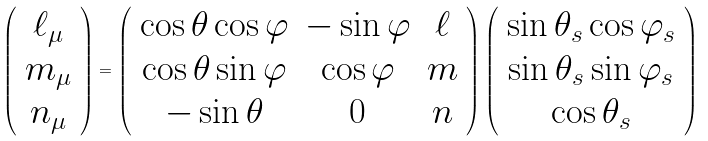Convert formula to latex. <formula><loc_0><loc_0><loc_500><loc_500>\left ( \begin{array} { c } \ell _ { \mu } \\ m _ { \mu } \\ n _ { \mu } \end{array} \right ) = \left ( \begin{array} { c c c } \cos \theta \cos \varphi & - \sin \varphi & \ell \\ \cos \theta \sin \varphi & \cos \varphi & m \\ - \sin \theta & 0 & n \end{array} \right ) \left ( \begin{array} { c } \sin \theta _ { s } \cos \varphi _ { s } \\ \sin \theta _ { s } \sin \varphi _ { s } \\ \cos \theta _ { s } \end{array} \right )</formula> 